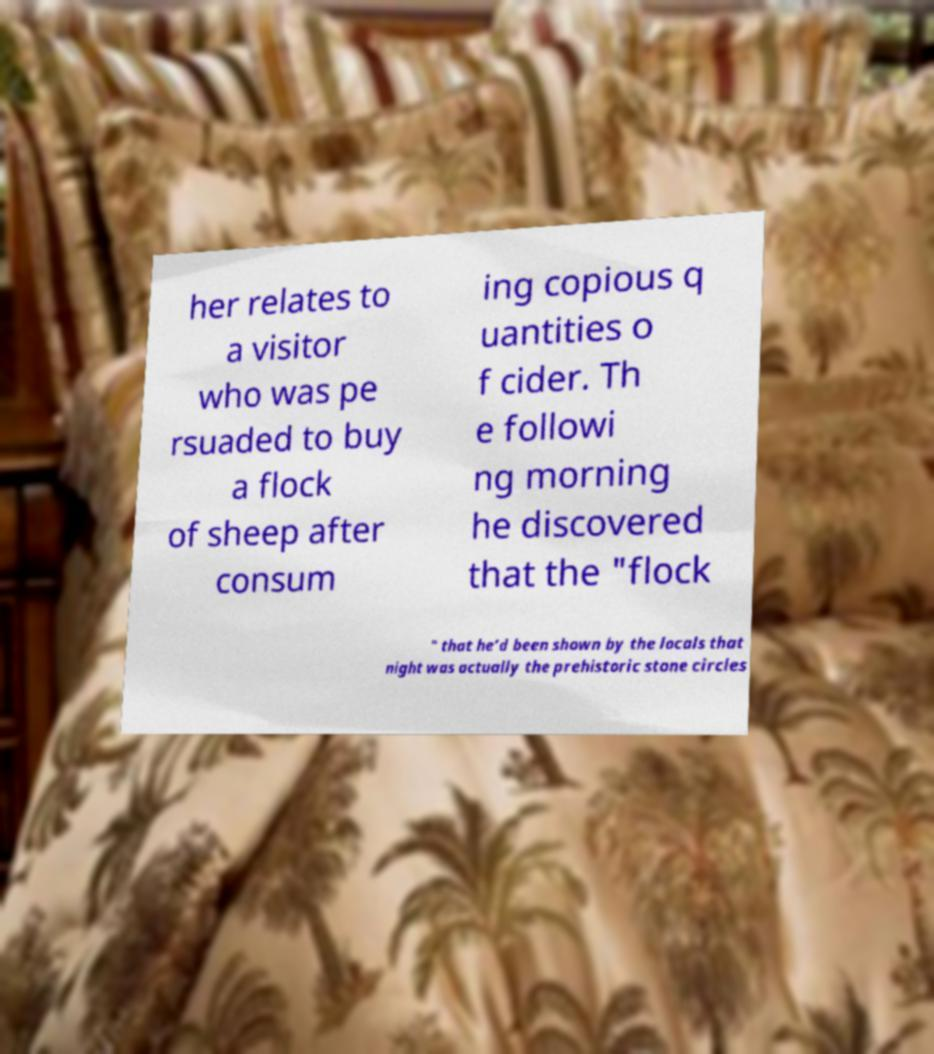Can you read and provide the text displayed in the image?This photo seems to have some interesting text. Can you extract and type it out for me? her relates to a visitor who was pe rsuaded to buy a flock of sheep after consum ing copious q uantities o f cider. Th e followi ng morning he discovered that the "flock " that he’d been shown by the locals that night was actually the prehistoric stone circles 